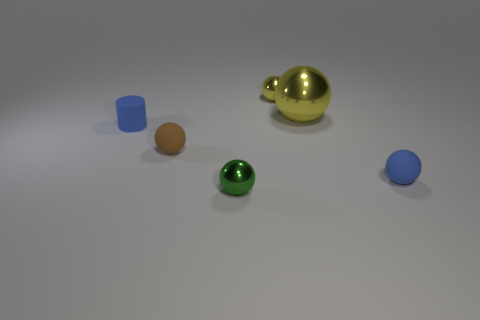There is a small shiny sphere that is behind the small sphere left of the shiny thing that is in front of the small brown object; what is its color?
Keep it short and to the point. Yellow. Does the green thing have the same size as the blue ball?
Your answer should be very brief. Yes. What number of blue spheres are the same size as the cylinder?
Provide a succinct answer. 1. There is a small shiny thing that is the same color as the large shiny ball; what is its shape?
Ensure brevity in your answer.  Sphere. Do the green ball that is in front of the small yellow ball and the blue object that is right of the blue cylinder have the same material?
Offer a terse response. No. Is there any other thing that has the same shape as the large object?
Offer a very short reply. Yes. What is the color of the rubber cylinder?
Provide a short and direct response. Blue. How many tiny yellow metal things have the same shape as the tiny brown thing?
Your answer should be compact. 1. There is a rubber cylinder that is the same size as the blue sphere; what color is it?
Make the answer very short. Blue. Are any small cyan matte blocks visible?
Keep it short and to the point. No. 